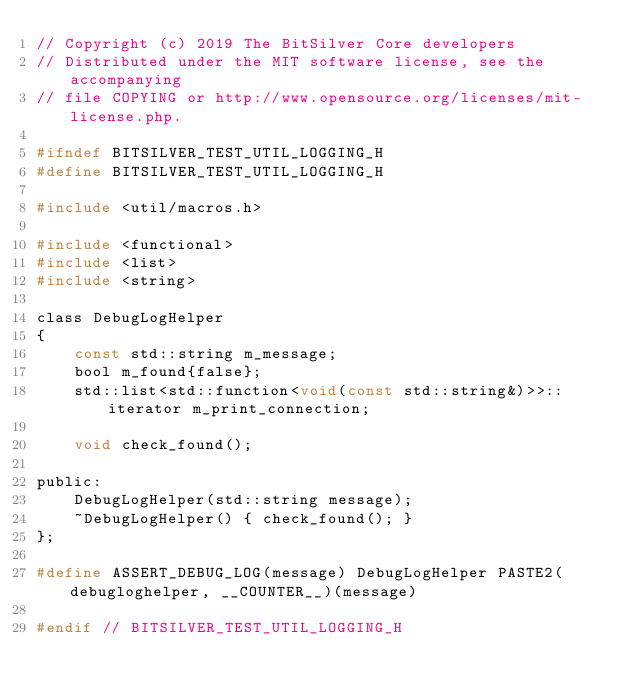Convert code to text. <code><loc_0><loc_0><loc_500><loc_500><_C_>// Copyright (c) 2019 The BitSilver Core developers
// Distributed under the MIT software license, see the accompanying
// file COPYING or http://www.opensource.org/licenses/mit-license.php.

#ifndef BITSILVER_TEST_UTIL_LOGGING_H
#define BITSILVER_TEST_UTIL_LOGGING_H

#include <util/macros.h>

#include <functional>
#include <list>
#include <string>

class DebugLogHelper
{
    const std::string m_message;
    bool m_found{false};
    std::list<std::function<void(const std::string&)>>::iterator m_print_connection;

    void check_found();

public:
    DebugLogHelper(std::string message);
    ~DebugLogHelper() { check_found(); }
};

#define ASSERT_DEBUG_LOG(message) DebugLogHelper PASTE2(debugloghelper, __COUNTER__)(message)

#endif // BITSILVER_TEST_UTIL_LOGGING_H
</code> 